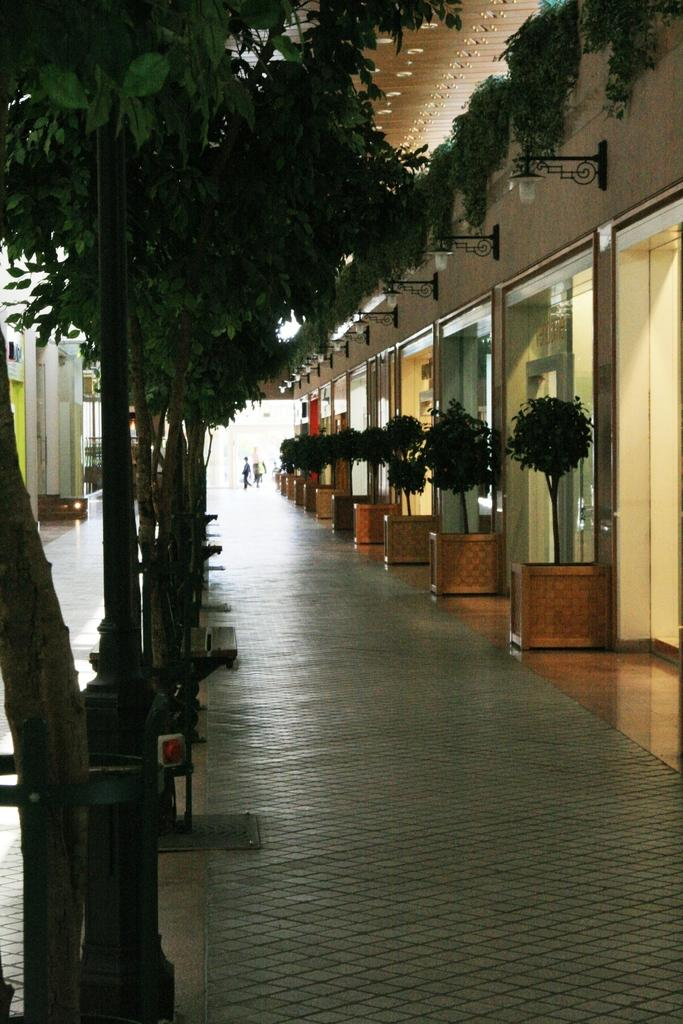What type of vegetation is on the left side of the image? There are trees on the left side of the image. What type of vegetation is on the right side of the image? There are plants on the right side of the image. What objects can be seen in the image that might be used for drinking? There are glasses in the image. What objects can be seen in the image that provide illumination? There are lights in the image. How many boys are sitting on the ant in the image? There are no boys or ants present in the image. 